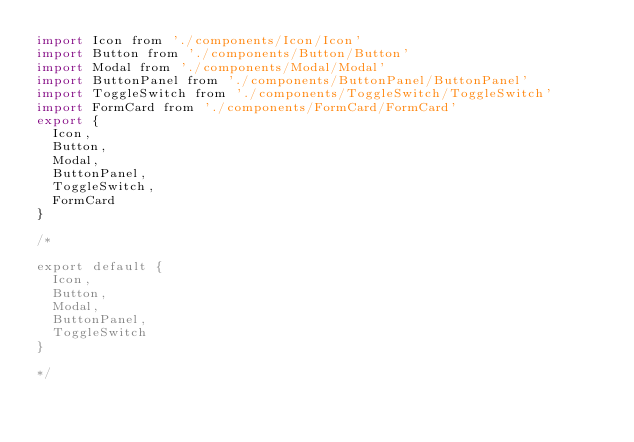<code> <loc_0><loc_0><loc_500><loc_500><_JavaScript_>import Icon from './components/Icon/Icon'
import Button from './components/Button/Button'
import Modal from './components/Modal/Modal'
import ButtonPanel from './components/ButtonPanel/ButtonPanel'
import ToggleSwitch from './components/ToggleSwitch/ToggleSwitch'
import FormCard from './components/FormCard/FormCard'
export {
	Icon,
	Button,
	Modal,
	ButtonPanel,
	ToggleSwitch,
	FormCard
}

/* 

export default {
	Icon,
	Button,
	Modal,
	ButtonPanel,
	ToggleSwitch
}

*/</code> 